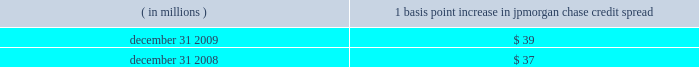Management 2019s discussion and analysis jpmorgan chase & co./2009 annual report 130 the following histogram illustrates the daily market risk 2013related gains and losses for ib and consumer/cio positions for 2009 .
The chart shows that the firm posted market risk 2013related gains on 227 out of 261 days in this period , with 69 days exceeding $ 160 million .
The inset graph looks at those days on which the firm experienced losses and depicts the amount by which the 95% ( 95 % ) confidence level var exceeded the actual loss on each of those days .
Losses were sustained on 34 days during 2009 and exceeded the var measure on one day due to high market volatility in the first quarter of 2009 .
Under the 95% ( 95 % ) confidence interval , the firm would expect to incur daily losses greater than that pre- dicted by var estimates about twelve times a year .
The table provides information about the gross sensitivity of dva to a one-basis-point increase in jpmorgan chase 2019s credit spreads .
This sensitivity represents the impact from a one-basis-point parallel shift in jpmorgan chase 2019s entire credit curve .
As credit curves do not typically move in a parallel fashion , the sensitivity multiplied by the change in spreads at a single maturity point may not be representative of the actual revenue recognized .
Debit valuation adjustment sensitivity 1 basis point increase in ( in millions ) jpmorgan chase credit spread .
Loss advisories and drawdowns loss advisories and drawdowns are tools used to highlight to senior management trading losses above certain levels and initiate discus- sion of remedies .
Economic value stress testing while var reflects the risk of loss due to adverse changes in normal markets , stress testing captures the firm 2019s exposure to unlikely but plausible events in abnormal markets .
The firm conducts economic- value stress tests using multiple scenarios that assume credit spreads widen significantly , equity prices decline and significant changes in interest rates across the major currencies .
Other scenar- ios focus on the risks predominant in individual business segments and include scenarios that focus on the potential for adverse movements in complex portfolios .
Scenarios were updated more frequently in 2009 and , in some cases , redefined to reflect the signifi- cant market volatility which began in late 2008 .
Along with var , stress testing is important in measuring and controlling risk .
Stress testing enhances the understanding of the firm 2019s risk profile and loss potential , and stress losses are monitored against limits .
Stress testing is also utilized in one-off approvals and cross-business risk measurement , as well as an input to economic capital allocation .
Stress-test results , trends and explanations based on current market risk positions are reported to the firm 2019s senior management and to the lines of business to help them better measure and manage risks and to understand event risk 2013sensitive positions. .
By how many trading days did the daily net gains exceed daily net losses? 
Computations: (227 - 34)
Answer: 193.0. 